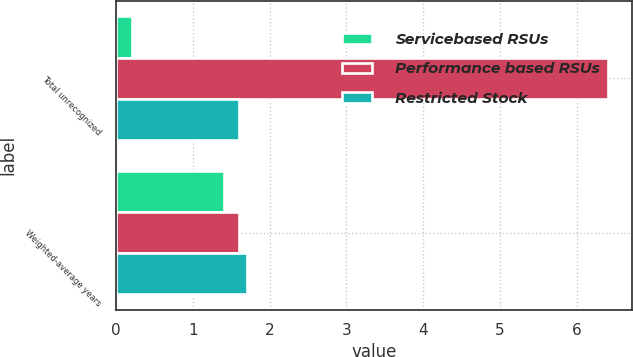Convert chart. <chart><loc_0><loc_0><loc_500><loc_500><stacked_bar_chart><ecel><fcel>Total unrecognized<fcel>Weighted-average years<nl><fcel>Servicebased RSUs<fcel>0.2<fcel>1.4<nl><fcel>Performance based RSUs<fcel>6.4<fcel>1.6<nl><fcel>Restricted Stock<fcel>1.6<fcel>1.7<nl></chart> 